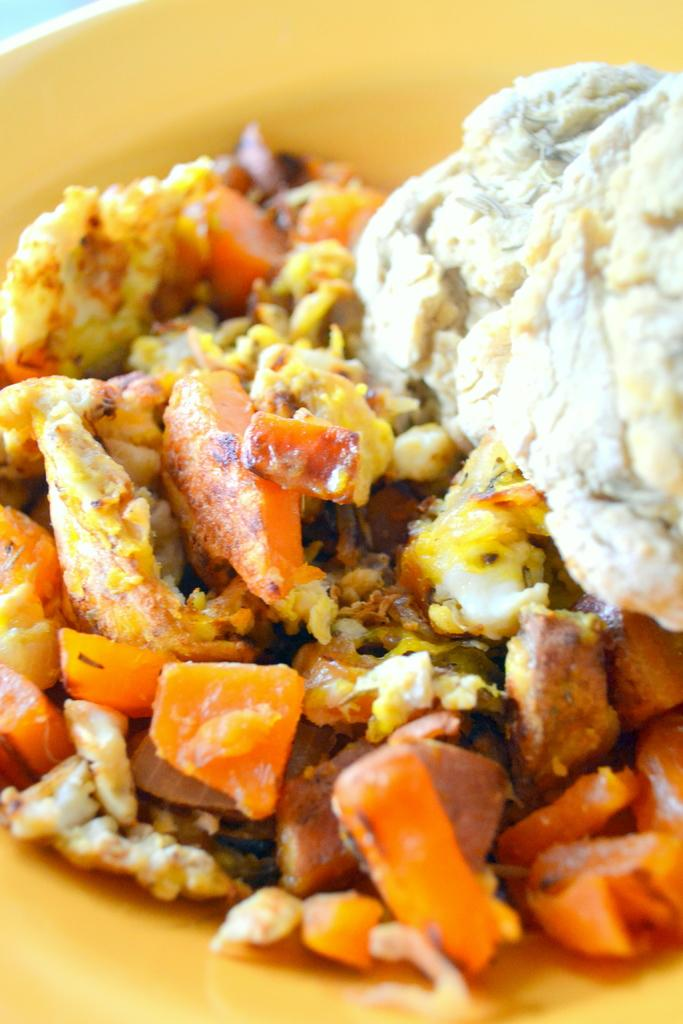Can you provide more information about the image so that we can discuss its contents? Unfortunately, there is not enough information in the transcript to extract specific facts about the image. Reasoning: Since there are no facts provided about the image, we cannot create a conversation based on specific details. Instead, we acknowledge the lack of information and encourage the user to provide more details so that we can proceed with the conversation. Absurd Question/Answer: How many trees are visible in the image? There is not enough information in the transcript to determine the presence or number of trees in the image. What type of wall is depicted in the image? There is not enough information in the transcript to determine the presence or type of wall in the image. What role does the governor play in the image? There is not enough information in the transcript to determine the presence or role of a governor in the image. 